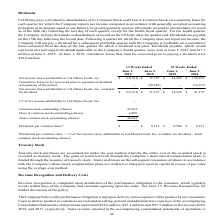Looking at Cal Maine Foods's financial data, please calculate: What is the increase / (decrease) in the Net income (loss) attributable to Cal-Maine Foods, Inc. available for dividend in 2019 compared to 2018? To answer this question, I need to perform calculations using the financial data. The calculation is: $(19,761) / $51,279 - 1, which equals -138.54 (percentage). This is based on the information: "e Foods, Inc. available for dividend $ (19,761) $ 51,279 $ 54,229 $ 51,279 1/3 of net income attributable to Cal-Maine Foods, Inc. — Common stock outstandin e (loss) attributable to Cal-Maine Foods, i..." The key data points involved are: 19,761, 51,279. Also, Except for the fourth fiscal year, on which day would the dividend be paid to the shareholders? 60th day following the last day of such quarter. The document states: "ends are paid to shareholders of record as of the 60th day following the last day of such quarter, except for the fourth fiscal quarter. For the fourt..." Also, can you calculate: What percentage of the class A common stock outstanding shares are a part of the total common stock outstanding shares? Based on the calculation: 4,800 / 48,694, the result is 9.86 (percentage). This is based on the information: "43,894 Class A common stock outstanding (shares) 4,800 Total common stock outstanding (shares) 48,694 es) 4,800 Total common stock outstanding (shares) 48,694..." The key data points involved are: 4,800, 48,694. Also, What was the dividend per common share in year ended June 2018? According to the financial document, $0.351. The relevant text states: "Dividends per common share* $ — $ 0.351 $ 0.506 $ 0.351..." Also, In the year ended 2019, what is the dividend per common share? According to the financial document, -. The relevant text states: "Cal-Maine pays a dividend to shareholders of its Common Stock and Class A Common Stock on a quarterly ba..." Also, can you calculate: What is the dividend payout ration in year ending June 2018? To answer this question, I need to perform calculations using the financial data. The calculation is: (48,694 * 0.351) / 51,279, which equals 33.33 (percentage). This is based on the information: "es) 4,800 Total common stock outstanding (shares) 48,694 Dividends per common share* $ — $ 0.351 $ 0.506 $ 0.351 e Foods, Inc. available for dividend $ (19,761) $ 51,279 $ 54,229 $ 51,279 1/3 of net i..." The key data points involved are: 0.351, 48,694, 51,279. 